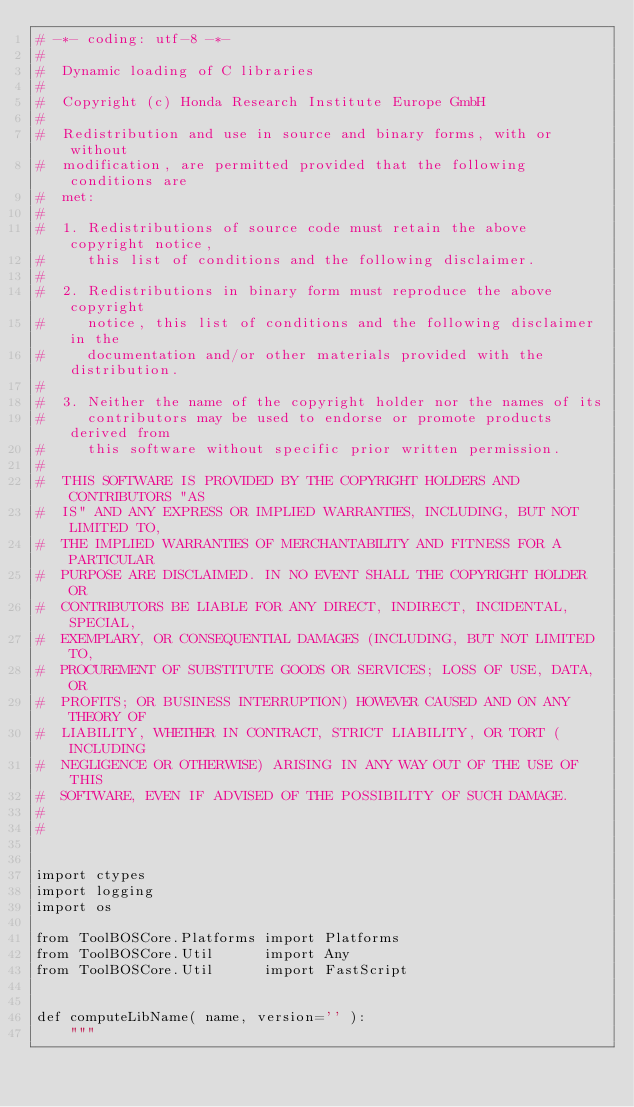Convert code to text. <code><loc_0><loc_0><loc_500><loc_500><_Python_># -*- coding: utf-8 -*-
#
#  Dynamic loading of C libraries
#
#  Copyright (c) Honda Research Institute Europe GmbH
#
#  Redistribution and use in source and binary forms, with or without
#  modification, are permitted provided that the following conditions are
#  met:
#
#  1. Redistributions of source code must retain the above copyright notice,
#     this list of conditions and the following disclaimer.
#
#  2. Redistributions in binary form must reproduce the above copyright
#     notice, this list of conditions and the following disclaimer in the
#     documentation and/or other materials provided with the distribution.
#
#  3. Neither the name of the copyright holder nor the names of its
#     contributors may be used to endorse or promote products derived from
#     this software without specific prior written permission.
#
#  THIS SOFTWARE IS PROVIDED BY THE COPYRIGHT HOLDERS AND CONTRIBUTORS "AS
#  IS" AND ANY EXPRESS OR IMPLIED WARRANTIES, INCLUDING, BUT NOT LIMITED TO,
#  THE IMPLIED WARRANTIES OF MERCHANTABILITY AND FITNESS FOR A PARTICULAR
#  PURPOSE ARE DISCLAIMED. IN NO EVENT SHALL THE COPYRIGHT HOLDER OR
#  CONTRIBUTORS BE LIABLE FOR ANY DIRECT, INDIRECT, INCIDENTAL, SPECIAL,
#  EXEMPLARY, OR CONSEQUENTIAL DAMAGES (INCLUDING, BUT NOT LIMITED TO,
#  PROCUREMENT OF SUBSTITUTE GOODS OR SERVICES; LOSS OF USE, DATA, OR
#  PROFITS; OR BUSINESS INTERRUPTION) HOWEVER CAUSED AND ON ANY THEORY OF
#  LIABILITY, WHETHER IN CONTRACT, STRICT LIABILITY, OR TORT (INCLUDING
#  NEGLIGENCE OR OTHERWISE) ARISING IN ANY WAY OUT OF THE USE OF THIS
#  SOFTWARE, EVEN IF ADVISED OF THE POSSIBILITY OF SUCH DAMAGE.
#
#


import ctypes
import logging
import os

from ToolBOSCore.Platforms import Platforms
from ToolBOSCore.Util      import Any
from ToolBOSCore.Util      import FastScript


def computeLibName( name, version='' ):
    """</code> 